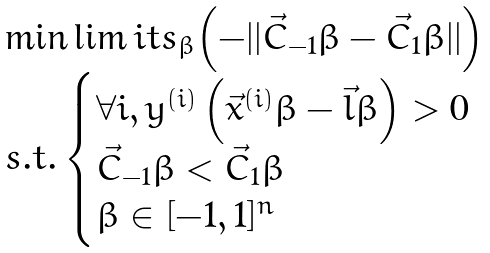Convert formula to latex. <formula><loc_0><loc_0><loc_500><loc_500>\begin{array} { l l } \min \lim i t s _ { \beta } { \left ( - | | \vec { C } _ { - 1 } \beta - \vec { C } _ { 1 } \beta | | \right ) } \\ s . t . \begin{cases} \forall i , y ^ { ( i ) } \left ( \vec { x } ^ { ( i ) } \beta - \vec { l } \beta \right ) > 0 \\ \vec { C } _ { - 1 } \beta < \vec { C } _ { 1 } \beta \\ \beta \in [ - 1 , 1 ] ^ { n } \end{cases} \end{array}</formula> 